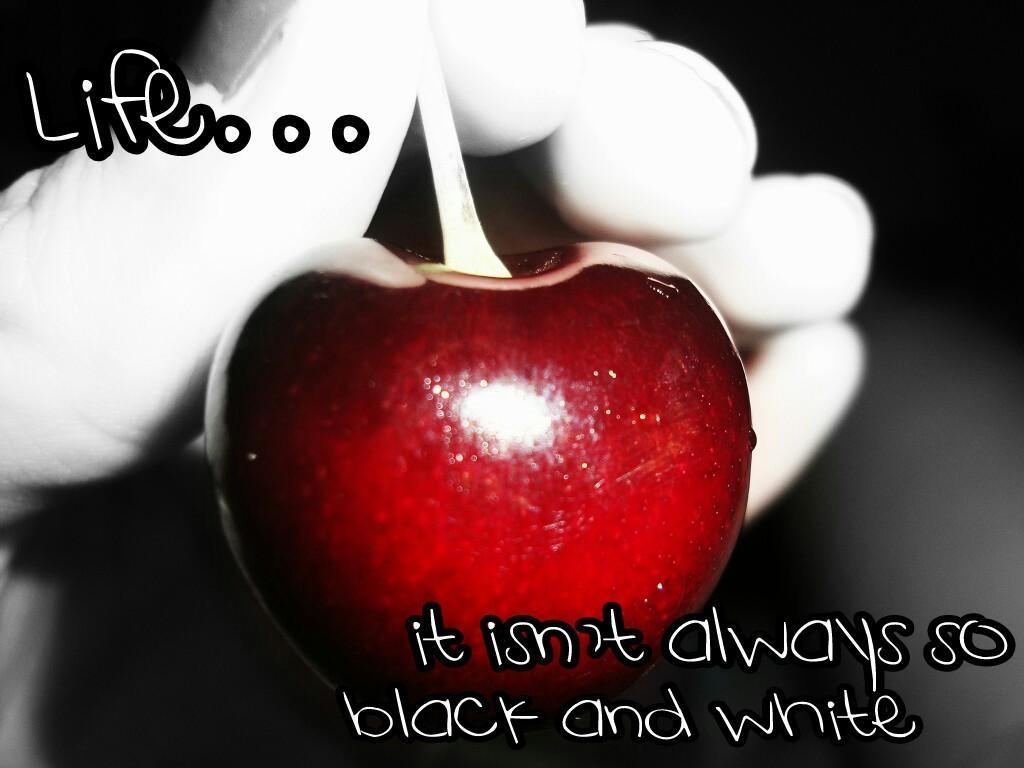Please provide a concise description of this image. In the picture we can see an apple, there are some words written. 